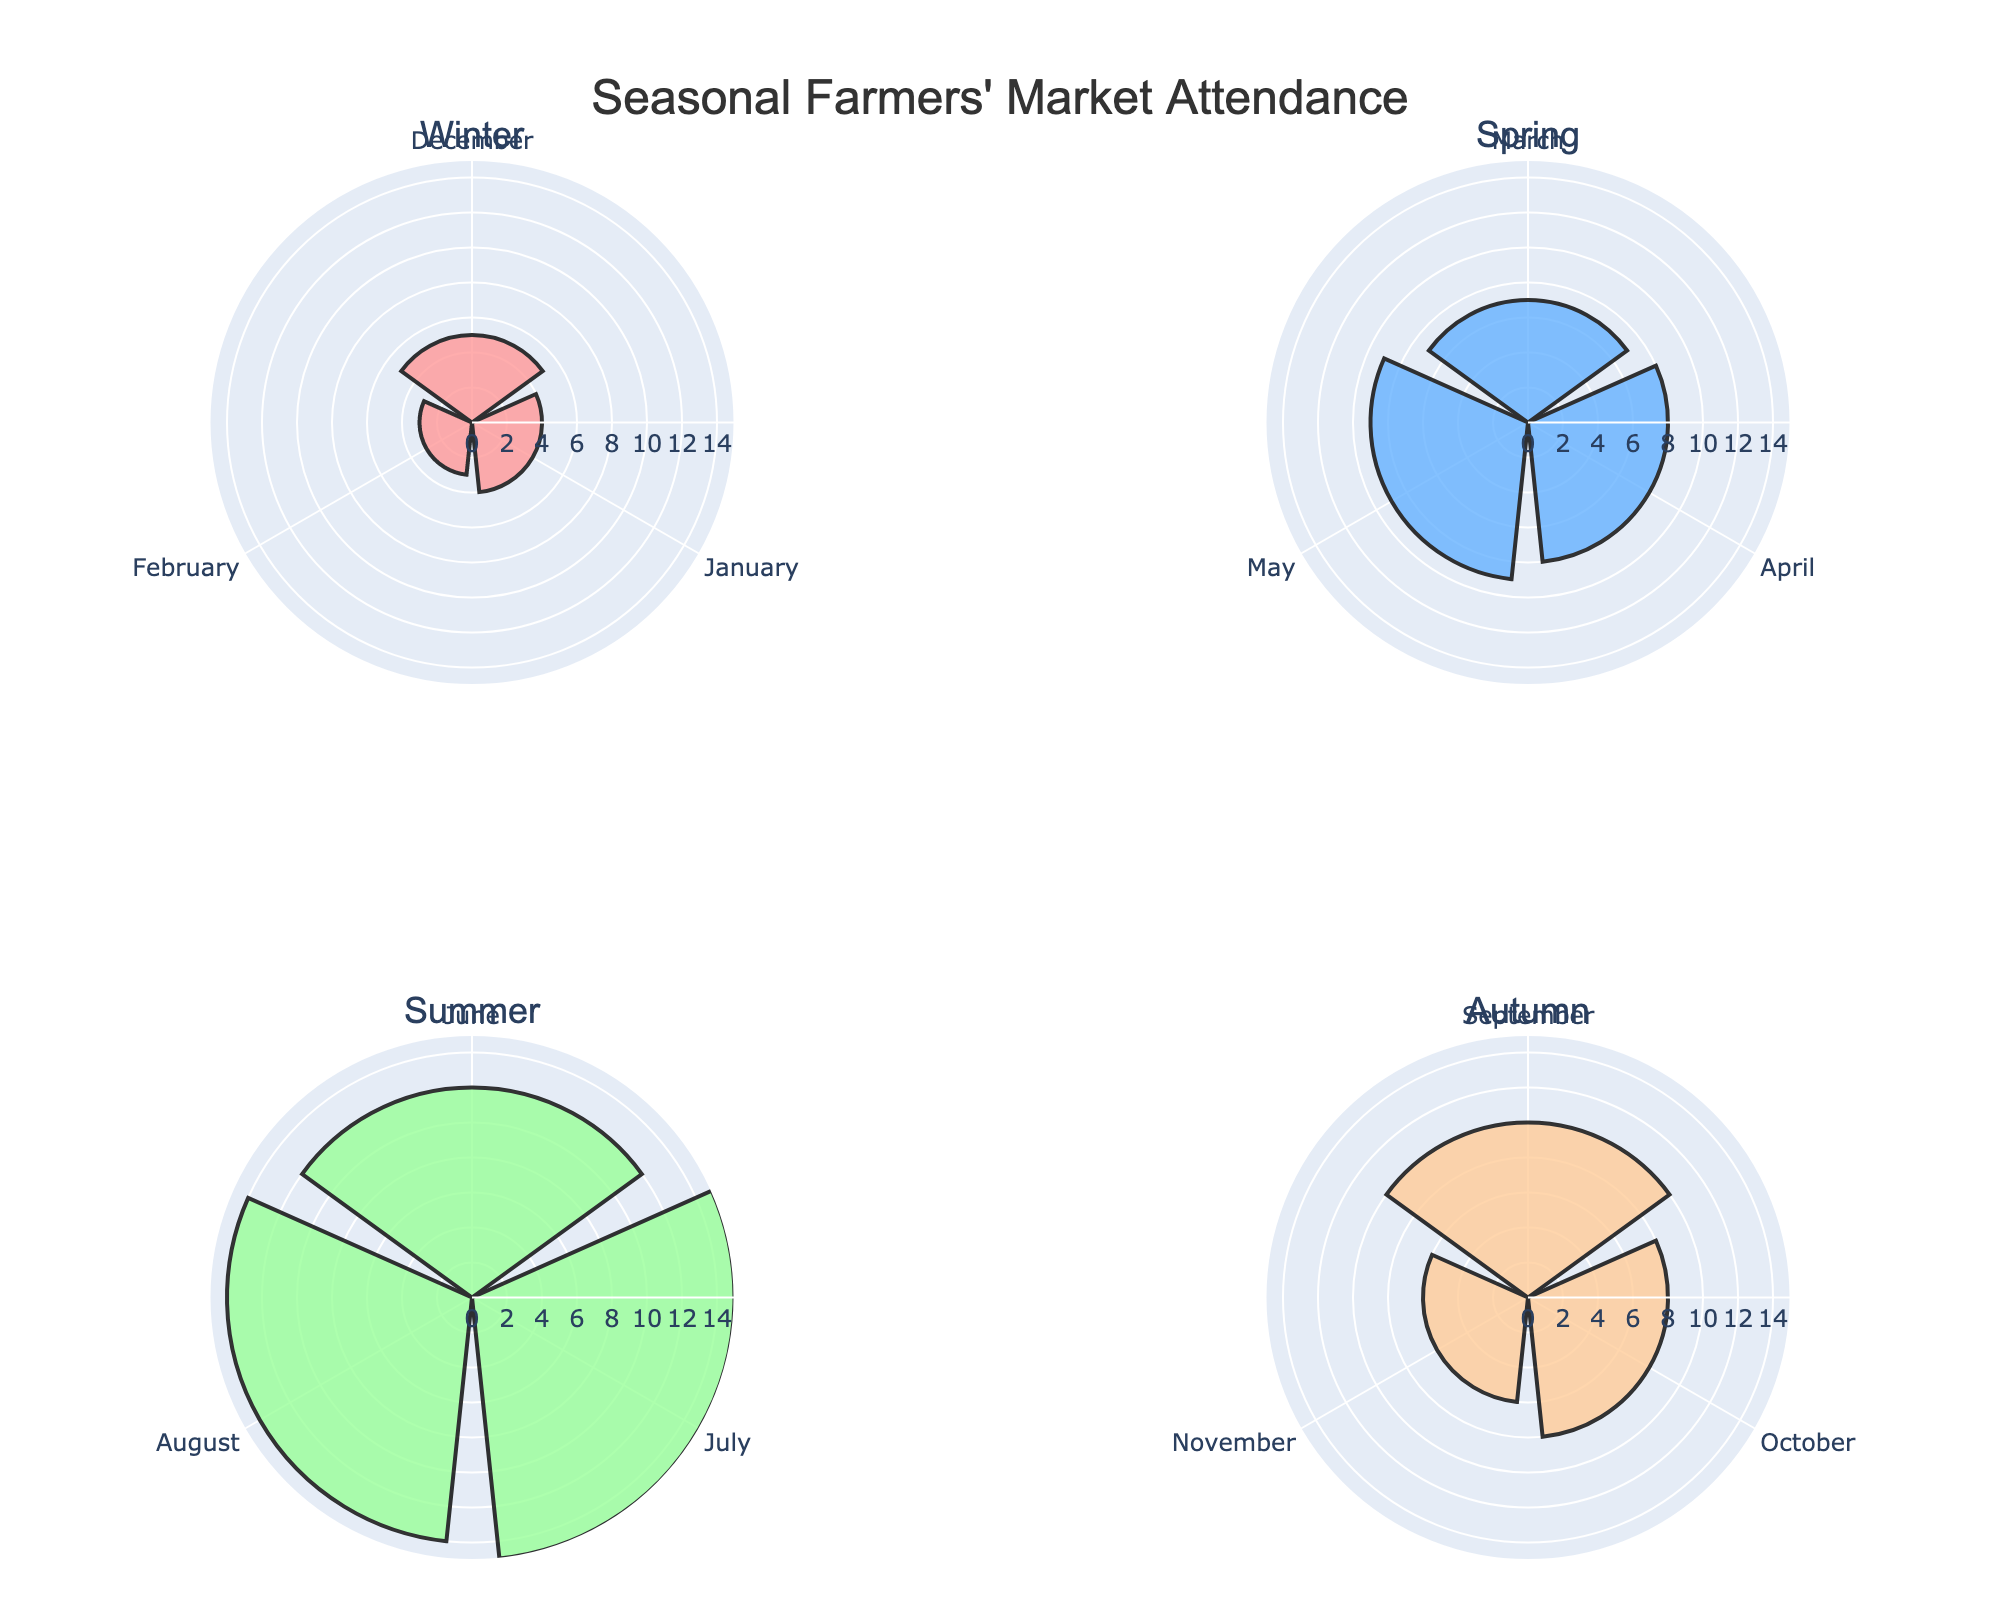What's the title of the figure? The title is placed at the top center of the figure and clearly states what the figure is about.
Answer: Seasonal Farmers' Market Attendance How many months are included in the Summer subplot? Each subplot for a season includes three months. Therefore, the Summer subplot includes June, July, and August.
Answer: 3 Which month has the highest market attendance in Summer? By looking at the radial bars in the Summer subplot, the bar for July is the tallest, indicating the highest attendance.
Answer: July Compare the market attendance between Spring and Autumn: which season has more total market attendances? Sum the attendances in each season: Spring (7 + 8 + 9 = 24) and Autumn (10 + 8 + 6 = 24). Both seasons have the same total attendance.
Answer: They are equal (24) Which season has the least market attendance on average per month? Calculate the average for each season: Winter ((5+4+3)/3=4), Spring ((7+8+9)/3=8), Summer ((12+15+14)/3=13.67), Autumn ((10+8+6)/3=8). Winter has the lowest average.
Answer: Winter Which season has the most varying market attendance between its months? Comparing the seasonal range: Winter (5-3=2), Spring (9-7=2), Summer (15-12=3), Autumn (10-6=4). Autumn has the highest variation.
Answer: Autumn What's the combined market attendance for Winter and Summer? Sum the attendances for each month in Winter and Summer: Winter (5+4+3=12) + Summer (12+15+14=41). Therefore, the combined total is 53.
Answer: 53 Which season shows a steady increase in market attendance from its first to its last month? Looking at the height of bars, only Spring shows a gradual increase from March (7) to April (8) to May (9).
Answer: Spring Is there any month with exactly 10 markets attended? If so, which month and season does it fall under? By inspecting the heights of the bars, September in the Autumn subplot corresponds to 10 markets attended.
Answer: September in Autumn 